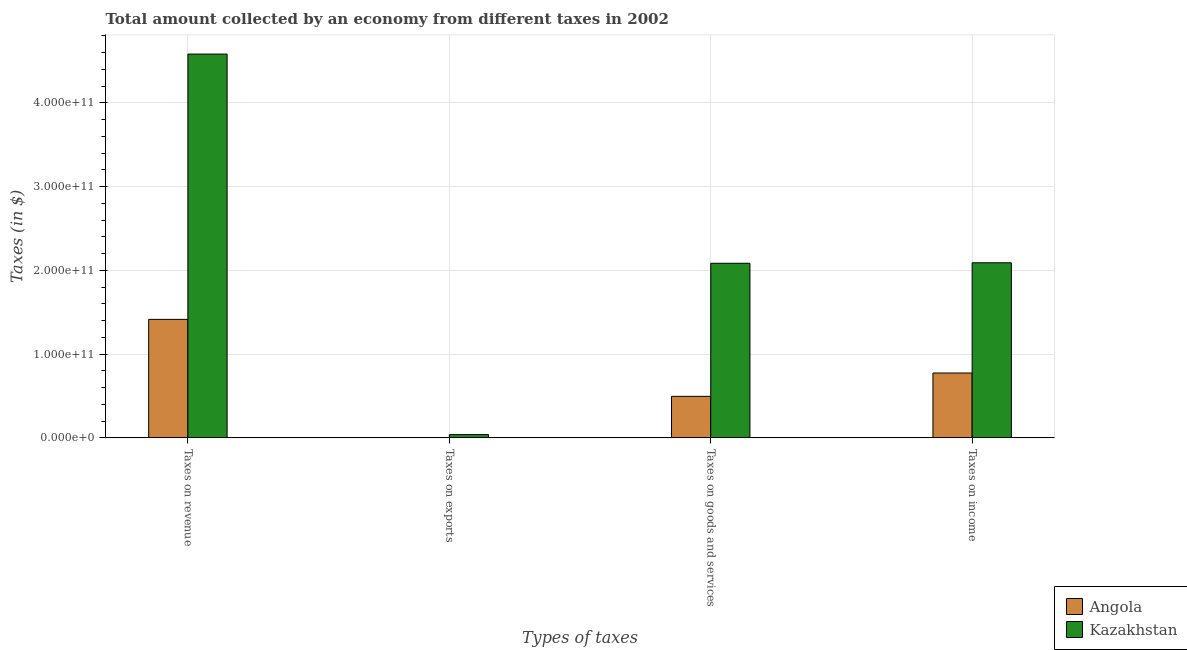How many bars are there on the 4th tick from the left?
Make the answer very short. 2. What is the label of the 1st group of bars from the left?
Ensure brevity in your answer.  Taxes on revenue. What is the amount collected as tax on exports in Angola?
Offer a very short reply. 2.48e+08. Across all countries, what is the maximum amount collected as tax on exports?
Provide a short and direct response. 3.89e+09. Across all countries, what is the minimum amount collected as tax on revenue?
Offer a very short reply. 1.41e+11. In which country was the amount collected as tax on revenue maximum?
Offer a very short reply. Kazakhstan. In which country was the amount collected as tax on income minimum?
Your answer should be compact. Angola. What is the total amount collected as tax on goods in the graph?
Give a very brief answer. 2.58e+11. What is the difference between the amount collected as tax on income in Kazakhstan and that in Angola?
Provide a succinct answer. 1.32e+11. What is the difference between the amount collected as tax on revenue in Kazakhstan and the amount collected as tax on goods in Angola?
Your answer should be very brief. 4.09e+11. What is the average amount collected as tax on income per country?
Offer a terse response. 1.43e+11. What is the difference between the amount collected as tax on goods and amount collected as tax on revenue in Kazakhstan?
Your answer should be very brief. -2.50e+11. What is the ratio of the amount collected as tax on income in Angola to that in Kazakhstan?
Keep it short and to the point. 0.37. Is the difference between the amount collected as tax on goods in Angola and Kazakhstan greater than the difference between the amount collected as tax on revenue in Angola and Kazakhstan?
Offer a terse response. Yes. What is the difference between the highest and the second highest amount collected as tax on goods?
Keep it short and to the point. 1.59e+11. What is the difference between the highest and the lowest amount collected as tax on income?
Your response must be concise. 1.32e+11. In how many countries, is the amount collected as tax on goods greater than the average amount collected as tax on goods taken over all countries?
Your response must be concise. 1. What does the 1st bar from the left in Taxes on revenue represents?
Your response must be concise. Angola. What does the 1st bar from the right in Taxes on exports represents?
Your answer should be compact. Kazakhstan. Is it the case that in every country, the sum of the amount collected as tax on revenue and amount collected as tax on exports is greater than the amount collected as tax on goods?
Give a very brief answer. Yes. How many bars are there?
Offer a very short reply. 8. How many countries are there in the graph?
Your response must be concise. 2. What is the difference between two consecutive major ticks on the Y-axis?
Provide a short and direct response. 1.00e+11. Are the values on the major ticks of Y-axis written in scientific E-notation?
Make the answer very short. Yes. Does the graph contain any zero values?
Offer a very short reply. No. Where does the legend appear in the graph?
Your response must be concise. Bottom right. How many legend labels are there?
Give a very brief answer. 2. What is the title of the graph?
Provide a succinct answer. Total amount collected by an economy from different taxes in 2002. Does "Guinea" appear as one of the legend labels in the graph?
Offer a very short reply. No. What is the label or title of the X-axis?
Offer a terse response. Types of taxes. What is the label or title of the Y-axis?
Your response must be concise. Taxes (in $). What is the Taxes (in $) in Angola in Taxes on revenue?
Your response must be concise. 1.41e+11. What is the Taxes (in $) of Kazakhstan in Taxes on revenue?
Provide a succinct answer. 4.58e+11. What is the Taxes (in $) in Angola in Taxes on exports?
Offer a terse response. 2.48e+08. What is the Taxes (in $) of Kazakhstan in Taxes on exports?
Ensure brevity in your answer.  3.89e+09. What is the Taxes (in $) in Angola in Taxes on goods and services?
Ensure brevity in your answer.  4.96e+1. What is the Taxes (in $) in Kazakhstan in Taxes on goods and services?
Make the answer very short. 2.08e+11. What is the Taxes (in $) of Angola in Taxes on income?
Offer a terse response. 7.74e+1. What is the Taxes (in $) of Kazakhstan in Taxes on income?
Offer a terse response. 2.09e+11. Across all Types of taxes, what is the maximum Taxes (in $) in Angola?
Offer a terse response. 1.41e+11. Across all Types of taxes, what is the maximum Taxes (in $) of Kazakhstan?
Your answer should be compact. 4.58e+11. Across all Types of taxes, what is the minimum Taxes (in $) in Angola?
Offer a terse response. 2.48e+08. Across all Types of taxes, what is the minimum Taxes (in $) in Kazakhstan?
Give a very brief answer. 3.89e+09. What is the total Taxes (in $) in Angola in the graph?
Ensure brevity in your answer.  2.69e+11. What is the total Taxes (in $) of Kazakhstan in the graph?
Make the answer very short. 8.80e+11. What is the difference between the Taxes (in $) in Angola in Taxes on revenue and that in Taxes on exports?
Provide a succinct answer. 1.41e+11. What is the difference between the Taxes (in $) in Kazakhstan in Taxes on revenue and that in Taxes on exports?
Provide a succinct answer. 4.54e+11. What is the difference between the Taxes (in $) of Angola in Taxes on revenue and that in Taxes on goods and services?
Provide a short and direct response. 9.19e+1. What is the difference between the Taxes (in $) in Kazakhstan in Taxes on revenue and that in Taxes on goods and services?
Ensure brevity in your answer.  2.50e+11. What is the difference between the Taxes (in $) of Angola in Taxes on revenue and that in Taxes on income?
Your answer should be very brief. 6.40e+1. What is the difference between the Taxes (in $) of Kazakhstan in Taxes on revenue and that in Taxes on income?
Offer a very short reply. 2.49e+11. What is the difference between the Taxes (in $) of Angola in Taxes on exports and that in Taxes on goods and services?
Give a very brief answer. -4.93e+1. What is the difference between the Taxes (in $) in Kazakhstan in Taxes on exports and that in Taxes on goods and services?
Provide a succinct answer. -2.05e+11. What is the difference between the Taxes (in $) of Angola in Taxes on exports and that in Taxes on income?
Make the answer very short. -7.72e+1. What is the difference between the Taxes (in $) in Kazakhstan in Taxes on exports and that in Taxes on income?
Your answer should be very brief. -2.05e+11. What is the difference between the Taxes (in $) of Angola in Taxes on goods and services and that in Taxes on income?
Offer a terse response. -2.79e+1. What is the difference between the Taxes (in $) in Kazakhstan in Taxes on goods and services and that in Taxes on income?
Ensure brevity in your answer.  -6.00e+08. What is the difference between the Taxes (in $) of Angola in Taxes on revenue and the Taxes (in $) of Kazakhstan in Taxes on exports?
Give a very brief answer. 1.38e+11. What is the difference between the Taxes (in $) in Angola in Taxes on revenue and the Taxes (in $) in Kazakhstan in Taxes on goods and services?
Offer a terse response. -6.70e+1. What is the difference between the Taxes (in $) in Angola in Taxes on revenue and the Taxes (in $) in Kazakhstan in Taxes on income?
Ensure brevity in your answer.  -6.76e+1. What is the difference between the Taxes (in $) in Angola in Taxes on exports and the Taxes (in $) in Kazakhstan in Taxes on goods and services?
Your answer should be very brief. -2.08e+11. What is the difference between the Taxes (in $) of Angola in Taxes on exports and the Taxes (in $) of Kazakhstan in Taxes on income?
Your response must be concise. -2.09e+11. What is the difference between the Taxes (in $) in Angola in Taxes on goods and services and the Taxes (in $) in Kazakhstan in Taxes on income?
Offer a very short reply. -1.59e+11. What is the average Taxes (in $) of Angola per Types of taxes?
Provide a succinct answer. 6.72e+1. What is the average Taxes (in $) in Kazakhstan per Types of taxes?
Make the answer very short. 2.20e+11. What is the difference between the Taxes (in $) in Angola and Taxes (in $) in Kazakhstan in Taxes on revenue?
Your response must be concise. -3.17e+11. What is the difference between the Taxes (in $) in Angola and Taxes (in $) in Kazakhstan in Taxes on exports?
Offer a very short reply. -3.64e+09. What is the difference between the Taxes (in $) in Angola and Taxes (in $) in Kazakhstan in Taxes on goods and services?
Your answer should be very brief. -1.59e+11. What is the difference between the Taxes (in $) in Angola and Taxes (in $) in Kazakhstan in Taxes on income?
Make the answer very short. -1.32e+11. What is the ratio of the Taxes (in $) in Angola in Taxes on revenue to that in Taxes on exports?
Provide a short and direct response. 570.12. What is the ratio of the Taxes (in $) in Kazakhstan in Taxes on revenue to that in Taxes on exports?
Offer a very short reply. 117.95. What is the ratio of the Taxes (in $) of Angola in Taxes on revenue to that in Taxes on goods and services?
Your answer should be very brief. 2.85. What is the ratio of the Taxes (in $) of Kazakhstan in Taxes on revenue to that in Taxes on goods and services?
Make the answer very short. 2.2. What is the ratio of the Taxes (in $) of Angola in Taxes on revenue to that in Taxes on income?
Offer a terse response. 1.83. What is the ratio of the Taxes (in $) in Kazakhstan in Taxes on revenue to that in Taxes on income?
Provide a short and direct response. 2.19. What is the ratio of the Taxes (in $) in Angola in Taxes on exports to that in Taxes on goods and services?
Ensure brevity in your answer.  0.01. What is the ratio of the Taxes (in $) of Kazakhstan in Taxes on exports to that in Taxes on goods and services?
Make the answer very short. 0.02. What is the ratio of the Taxes (in $) in Angola in Taxes on exports to that in Taxes on income?
Make the answer very short. 0. What is the ratio of the Taxes (in $) in Kazakhstan in Taxes on exports to that in Taxes on income?
Offer a very short reply. 0.02. What is the ratio of the Taxes (in $) of Angola in Taxes on goods and services to that in Taxes on income?
Offer a very short reply. 0.64. What is the ratio of the Taxes (in $) in Kazakhstan in Taxes on goods and services to that in Taxes on income?
Keep it short and to the point. 1. What is the difference between the highest and the second highest Taxes (in $) of Angola?
Provide a short and direct response. 6.40e+1. What is the difference between the highest and the second highest Taxes (in $) of Kazakhstan?
Keep it short and to the point. 2.49e+11. What is the difference between the highest and the lowest Taxes (in $) in Angola?
Your answer should be very brief. 1.41e+11. What is the difference between the highest and the lowest Taxes (in $) in Kazakhstan?
Ensure brevity in your answer.  4.54e+11. 